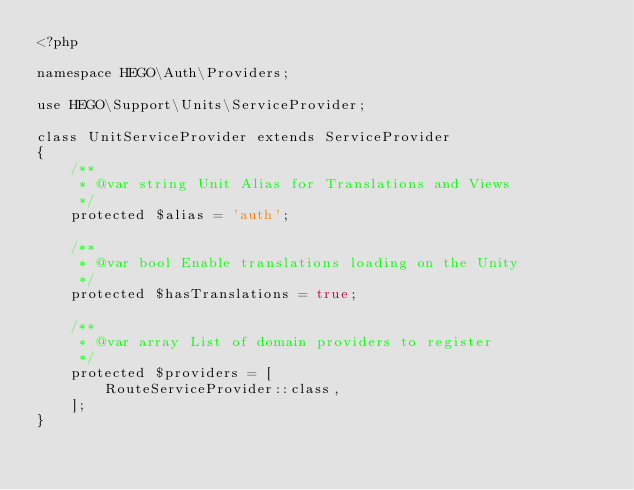Convert code to text. <code><loc_0><loc_0><loc_500><loc_500><_PHP_><?php

namespace HEGO\Auth\Providers;

use HEGO\Support\Units\ServiceProvider;

class UnitServiceProvider extends ServiceProvider
{
    /**
     * @var string Unit Alias for Translations and Views
     */
    protected $alias = 'auth';

    /**
     * @var bool Enable translations loading on the Unity
     */
    protected $hasTranslations = true;

    /**
     * @var array List of domain providers to register
     */
    protected $providers = [
        RouteServiceProvider::class,
    ];
}</code> 